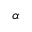Convert formula to latex. <formula><loc_0><loc_0><loc_500><loc_500>\alpha</formula> 